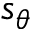<formula> <loc_0><loc_0><loc_500><loc_500>s _ { \theta }</formula> 